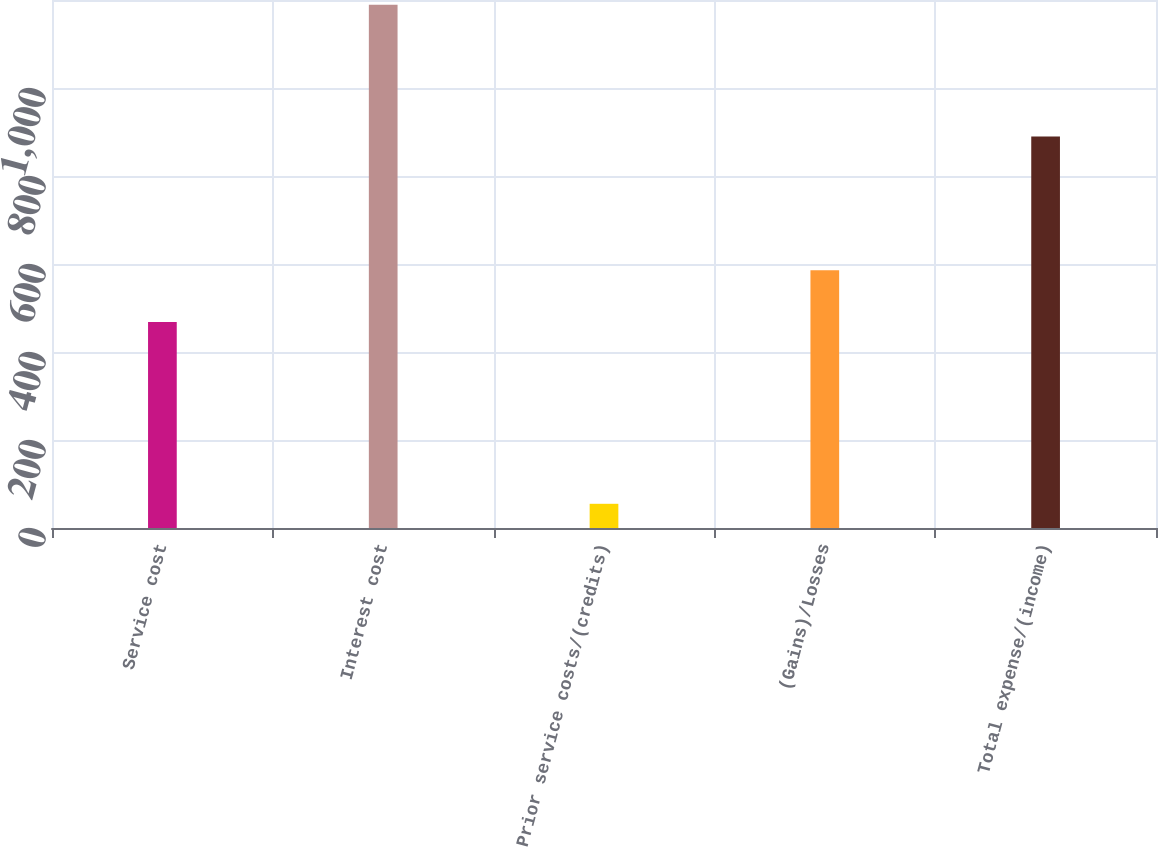Convert chart. <chart><loc_0><loc_0><loc_500><loc_500><bar_chart><fcel>Service cost<fcel>Interest cost<fcel>Prior service costs/(credits)<fcel>(Gains)/Losses<fcel>Total expense/(income)<nl><fcel>468<fcel>1189<fcel>55<fcel>586<fcel>890<nl></chart> 